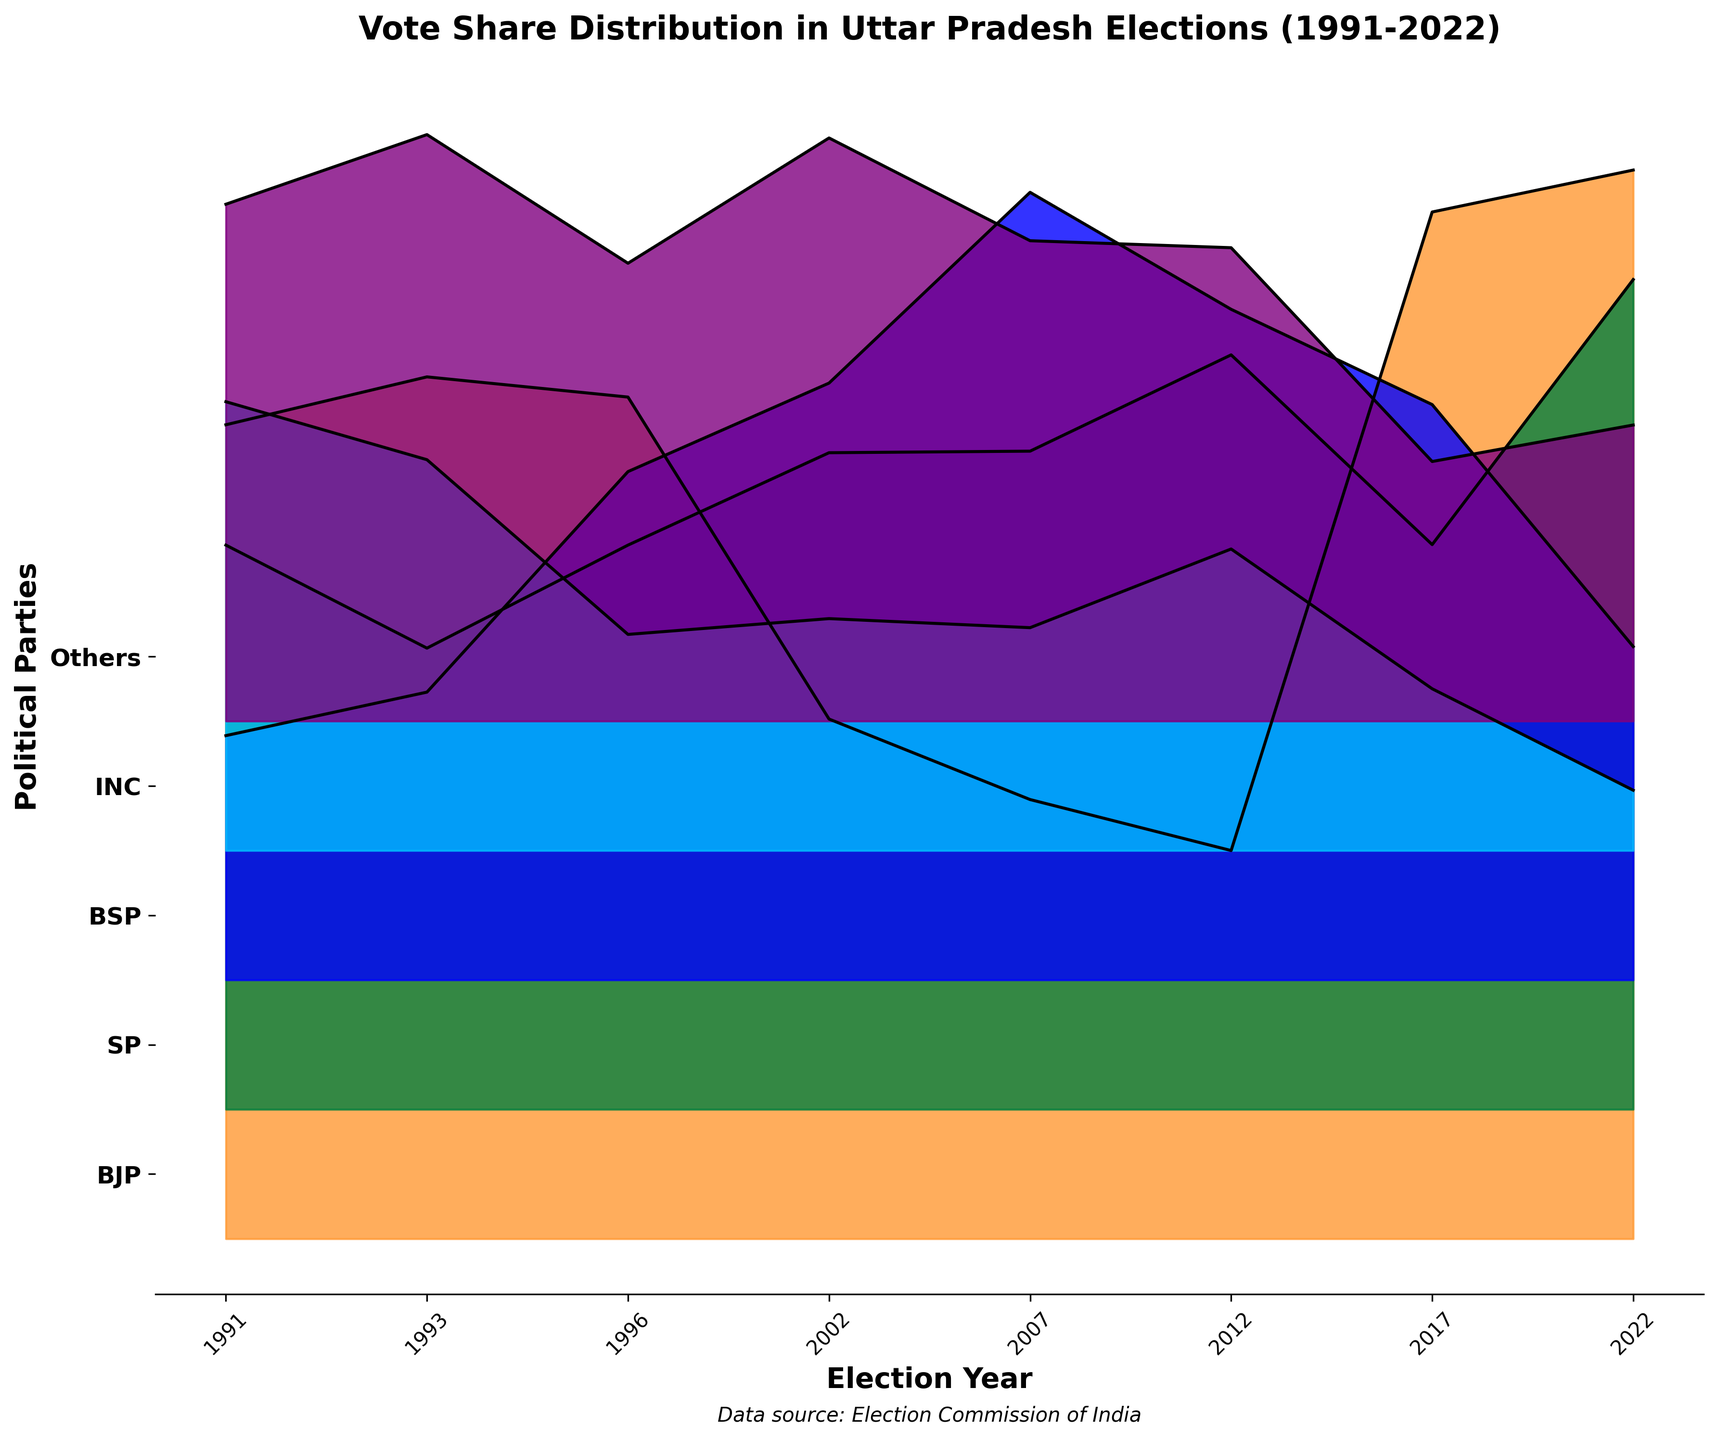What is the title of the plot? The title of the plot is written at the top and provides information about the overall content of the figure. Here, it says 'Vote Share Distribution in Uttar Pradesh Elections (1991-2022)'.
Answer: Vote Share Distribution in Uttar Pradesh Elections (1991-2022) Which year showed the highest vote share for the BJP? To determine this, look at the ridgeline plot and see where the BJP line peaks the highest. The peak occurs in 2022 where the vote share reaches 41.29%.
Answer: 2022 What colors represent the different political parties in the plot? Each party is represented by a unique color. BJP is orange, SP is green, BSP is blue, INC is light blue, and Others is purple. These colors help differentiate between the parties on the plot.
Answer: Orange for BJP, Green for SP, Blue for BSP, Light Blue for INC, Purple for Others In which year did the INC have its lowest vote share? By comparing the heights of the ridgeline across years, it is clear that the INC has its lowest vote share in 2022, where it reaches only 2.33%.
Answer: 2022 How does the SP's vote share in 2022 compare to its vote share in 2017? The plot shows SP's vote share in 2017 is 21.82% and in 2022 it is 32.06%. By comparing these values, we see that SP's vote share increased.
Answer: Increased Which party had the most consistent vote share over the years? A visual inspection shows that the SP's vote share line fluctuates the least compared to other parties, indicating more consistency.
Answer: SP In what year did the vote share of the BSP peak, and what was the share? Examine the blue ridgeline for the BSP and find the highest point, which occurs in 2007 with a vote share of 30.43%.
Answer: 2007, 30.43% How does the vote share of Others in 1991 compare to the vote share of INC in 2002? In 1991, Others had a vote share of 19.97%, while INC in 2002 had a vote share of 8.96%. Thus, Others had a higher vote share in 1991 compared to INC in 2002.
Answer: Higher What is the general trend of BJP's vote share from 1991 to 2022? Looking at the ridgeline plot for BJP, there's a noticeable dip around 2002 and 2007 but an upward trend starting in 2012, peaking in 2022.
Answer: Upward trend 